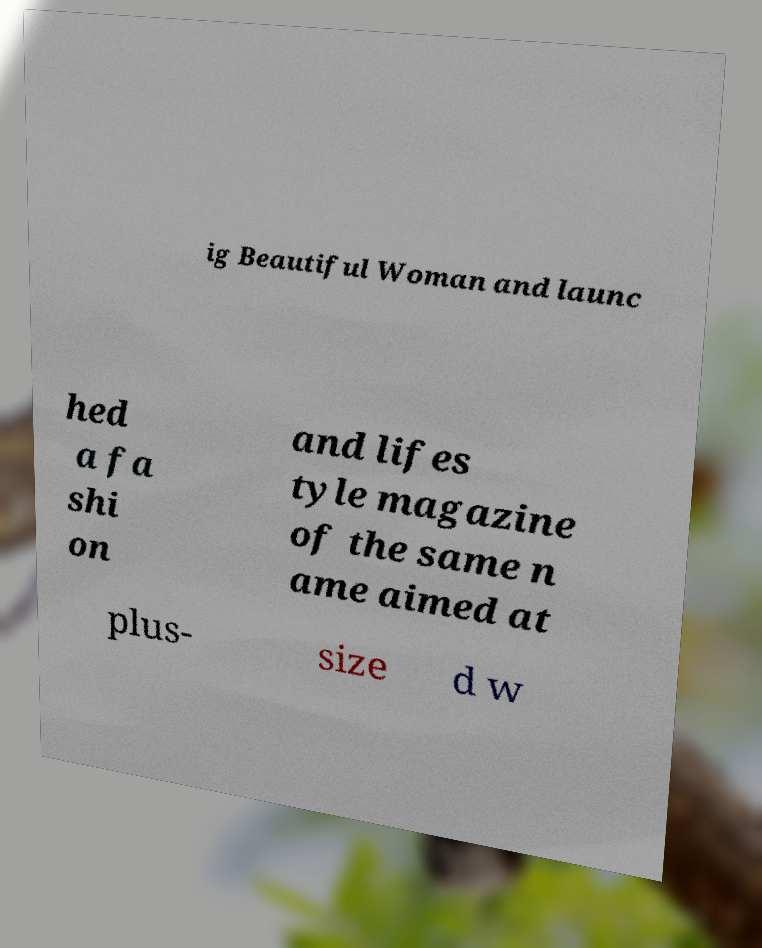For documentation purposes, I need the text within this image transcribed. Could you provide that? ig Beautiful Woman and launc hed a fa shi on and lifes tyle magazine of the same n ame aimed at plus- size d w 